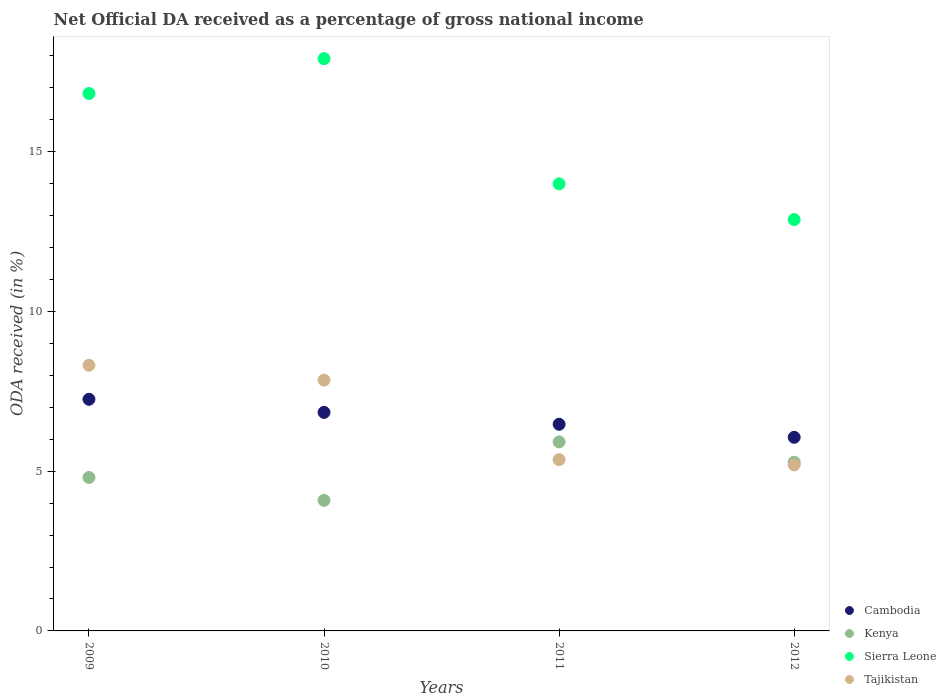How many different coloured dotlines are there?
Your answer should be compact. 4. Is the number of dotlines equal to the number of legend labels?
Your answer should be very brief. Yes. What is the net official DA received in Cambodia in 2011?
Offer a very short reply. 6.47. Across all years, what is the maximum net official DA received in Tajikistan?
Provide a succinct answer. 8.32. Across all years, what is the minimum net official DA received in Sierra Leone?
Offer a very short reply. 12.87. In which year was the net official DA received in Kenya maximum?
Your answer should be very brief. 2011. In which year was the net official DA received in Sierra Leone minimum?
Keep it short and to the point. 2012. What is the total net official DA received in Kenya in the graph?
Provide a succinct answer. 20.09. What is the difference between the net official DA received in Cambodia in 2009 and that in 2012?
Keep it short and to the point. 1.19. What is the difference between the net official DA received in Sierra Leone in 2009 and the net official DA received in Cambodia in 2012?
Offer a terse response. 10.76. What is the average net official DA received in Kenya per year?
Your answer should be very brief. 5.02. In the year 2009, what is the difference between the net official DA received in Cambodia and net official DA received in Tajikistan?
Your response must be concise. -1.07. In how many years, is the net official DA received in Cambodia greater than 2 %?
Your response must be concise. 4. What is the ratio of the net official DA received in Kenya in 2011 to that in 2012?
Provide a short and direct response. 1.12. What is the difference between the highest and the second highest net official DA received in Kenya?
Keep it short and to the point. 0.64. What is the difference between the highest and the lowest net official DA received in Tajikistan?
Offer a very short reply. 3.12. In how many years, is the net official DA received in Cambodia greater than the average net official DA received in Cambodia taken over all years?
Provide a succinct answer. 2. Is the sum of the net official DA received in Kenya in 2009 and 2010 greater than the maximum net official DA received in Tajikistan across all years?
Provide a succinct answer. Yes. Is it the case that in every year, the sum of the net official DA received in Kenya and net official DA received in Cambodia  is greater than the net official DA received in Tajikistan?
Offer a very short reply. Yes. Does the net official DA received in Sierra Leone monotonically increase over the years?
Give a very brief answer. No. Is the net official DA received in Sierra Leone strictly greater than the net official DA received in Cambodia over the years?
Provide a succinct answer. Yes. How many years are there in the graph?
Offer a terse response. 4. Are the values on the major ticks of Y-axis written in scientific E-notation?
Your answer should be very brief. No. Does the graph contain any zero values?
Provide a succinct answer. No. What is the title of the graph?
Your response must be concise. Net Official DA received as a percentage of gross national income. What is the label or title of the X-axis?
Make the answer very short. Years. What is the label or title of the Y-axis?
Your answer should be compact. ODA received (in %). What is the ODA received (in %) of Cambodia in 2009?
Give a very brief answer. 7.25. What is the ODA received (in %) in Kenya in 2009?
Provide a succinct answer. 4.8. What is the ODA received (in %) in Sierra Leone in 2009?
Make the answer very short. 16.82. What is the ODA received (in %) of Tajikistan in 2009?
Provide a succinct answer. 8.32. What is the ODA received (in %) in Cambodia in 2010?
Your answer should be compact. 6.84. What is the ODA received (in %) of Kenya in 2010?
Provide a succinct answer. 4.09. What is the ODA received (in %) of Sierra Leone in 2010?
Your response must be concise. 17.91. What is the ODA received (in %) in Tajikistan in 2010?
Offer a terse response. 7.85. What is the ODA received (in %) in Cambodia in 2011?
Ensure brevity in your answer.  6.47. What is the ODA received (in %) of Kenya in 2011?
Provide a short and direct response. 5.92. What is the ODA received (in %) of Sierra Leone in 2011?
Offer a terse response. 13.99. What is the ODA received (in %) in Tajikistan in 2011?
Give a very brief answer. 5.36. What is the ODA received (in %) in Cambodia in 2012?
Your response must be concise. 6.06. What is the ODA received (in %) in Kenya in 2012?
Provide a short and direct response. 5.28. What is the ODA received (in %) in Sierra Leone in 2012?
Provide a succinct answer. 12.87. What is the ODA received (in %) of Tajikistan in 2012?
Give a very brief answer. 5.2. Across all years, what is the maximum ODA received (in %) in Cambodia?
Offer a very short reply. 7.25. Across all years, what is the maximum ODA received (in %) of Kenya?
Give a very brief answer. 5.92. Across all years, what is the maximum ODA received (in %) in Sierra Leone?
Your answer should be compact. 17.91. Across all years, what is the maximum ODA received (in %) of Tajikistan?
Your answer should be compact. 8.32. Across all years, what is the minimum ODA received (in %) of Cambodia?
Offer a terse response. 6.06. Across all years, what is the minimum ODA received (in %) of Kenya?
Your answer should be very brief. 4.09. Across all years, what is the minimum ODA received (in %) of Sierra Leone?
Ensure brevity in your answer.  12.87. Across all years, what is the minimum ODA received (in %) in Tajikistan?
Provide a succinct answer. 5.2. What is the total ODA received (in %) of Cambodia in the graph?
Offer a terse response. 26.62. What is the total ODA received (in %) in Kenya in the graph?
Offer a very short reply. 20.09. What is the total ODA received (in %) of Sierra Leone in the graph?
Offer a terse response. 61.6. What is the total ODA received (in %) of Tajikistan in the graph?
Offer a very short reply. 26.72. What is the difference between the ODA received (in %) of Cambodia in 2009 and that in 2010?
Provide a short and direct response. 0.41. What is the difference between the ODA received (in %) of Kenya in 2009 and that in 2010?
Offer a terse response. 0.72. What is the difference between the ODA received (in %) in Sierra Leone in 2009 and that in 2010?
Keep it short and to the point. -1.09. What is the difference between the ODA received (in %) in Tajikistan in 2009 and that in 2010?
Your response must be concise. 0.47. What is the difference between the ODA received (in %) of Cambodia in 2009 and that in 2011?
Your response must be concise. 0.78. What is the difference between the ODA received (in %) in Kenya in 2009 and that in 2011?
Your answer should be very brief. -1.11. What is the difference between the ODA received (in %) in Sierra Leone in 2009 and that in 2011?
Give a very brief answer. 2.83. What is the difference between the ODA received (in %) of Tajikistan in 2009 and that in 2011?
Provide a short and direct response. 2.95. What is the difference between the ODA received (in %) in Cambodia in 2009 and that in 2012?
Keep it short and to the point. 1.19. What is the difference between the ODA received (in %) of Kenya in 2009 and that in 2012?
Your answer should be compact. -0.48. What is the difference between the ODA received (in %) in Sierra Leone in 2009 and that in 2012?
Offer a terse response. 3.95. What is the difference between the ODA received (in %) of Tajikistan in 2009 and that in 2012?
Your answer should be compact. 3.12. What is the difference between the ODA received (in %) in Cambodia in 2010 and that in 2011?
Your answer should be very brief. 0.37. What is the difference between the ODA received (in %) of Kenya in 2010 and that in 2011?
Give a very brief answer. -1.83. What is the difference between the ODA received (in %) in Sierra Leone in 2010 and that in 2011?
Your answer should be compact. 3.92. What is the difference between the ODA received (in %) in Tajikistan in 2010 and that in 2011?
Make the answer very short. 2.49. What is the difference between the ODA received (in %) in Cambodia in 2010 and that in 2012?
Your response must be concise. 0.78. What is the difference between the ODA received (in %) in Kenya in 2010 and that in 2012?
Offer a very short reply. -1.19. What is the difference between the ODA received (in %) in Sierra Leone in 2010 and that in 2012?
Your answer should be very brief. 5.04. What is the difference between the ODA received (in %) in Tajikistan in 2010 and that in 2012?
Your response must be concise. 2.65. What is the difference between the ODA received (in %) in Cambodia in 2011 and that in 2012?
Your answer should be compact. 0.41. What is the difference between the ODA received (in %) of Kenya in 2011 and that in 2012?
Make the answer very short. 0.64. What is the difference between the ODA received (in %) of Sierra Leone in 2011 and that in 2012?
Ensure brevity in your answer.  1.12. What is the difference between the ODA received (in %) of Tajikistan in 2011 and that in 2012?
Your answer should be compact. 0.16. What is the difference between the ODA received (in %) of Cambodia in 2009 and the ODA received (in %) of Kenya in 2010?
Offer a terse response. 3.16. What is the difference between the ODA received (in %) in Cambodia in 2009 and the ODA received (in %) in Sierra Leone in 2010?
Make the answer very short. -10.66. What is the difference between the ODA received (in %) in Cambodia in 2009 and the ODA received (in %) in Tajikistan in 2010?
Make the answer very short. -0.6. What is the difference between the ODA received (in %) in Kenya in 2009 and the ODA received (in %) in Sierra Leone in 2010?
Give a very brief answer. -13.11. What is the difference between the ODA received (in %) in Kenya in 2009 and the ODA received (in %) in Tajikistan in 2010?
Ensure brevity in your answer.  -3.04. What is the difference between the ODA received (in %) in Sierra Leone in 2009 and the ODA received (in %) in Tajikistan in 2010?
Provide a succinct answer. 8.97. What is the difference between the ODA received (in %) in Cambodia in 2009 and the ODA received (in %) in Kenya in 2011?
Keep it short and to the point. 1.33. What is the difference between the ODA received (in %) in Cambodia in 2009 and the ODA received (in %) in Sierra Leone in 2011?
Your response must be concise. -6.74. What is the difference between the ODA received (in %) of Cambodia in 2009 and the ODA received (in %) of Tajikistan in 2011?
Give a very brief answer. 1.89. What is the difference between the ODA received (in %) of Kenya in 2009 and the ODA received (in %) of Sierra Leone in 2011?
Provide a succinct answer. -9.19. What is the difference between the ODA received (in %) in Kenya in 2009 and the ODA received (in %) in Tajikistan in 2011?
Offer a terse response. -0.56. What is the difference between the ODA received (in %) of Sierra Leone in 2009 and the ODA received (in %) of Tajikistan in 2011?
Offer a terse response. 11.46. What is the difference between the ODA received (in %) of Cambodia in 2009 and the ODA received (in %) of Kenya in 2012?
Offer a terse response. 1.97. What is the difference between the ODA received (in %) in Cambodia in 2009 and the ODA received (in %) in Sierra Leone in 2012?
Provide a short and direct response. -5.62. What is the difference between the ODA received (in %) of Cambodia in 2009 and the ODA received (in %) of Tajikistan in 2012?
Provide a succinct answer. 2.05. What is the difference between the ODA received (in %) in Kenya in 2009 and the ODA received (in %) in Sierra Leone in 2012?
Make the answer very short. -8.07. What is the difference between the ODA received (in %) of Kenya in 2009 and the ODA received (in %) of Tajikistan in 2012?
Provide a short and direct response. -0.39. What is the difference between the ODA received (in %) in Sierra Leone in 2009 and the ODA received (in %) in Tajikistan in 2012?
Your response must be concise. 11.62. What is the difference between the ODA received (in %) of Cambodia in 2010 and the ODA received (in %) of Kenya in 2011?
Offer a very short reply. 0.92. What is the difference between the ODA received (in %) of Cambodia in 2010 and the ODA received (in %) of Sierra Leone in 2011?
Give a very brief answer. -7.15. What is the difference between the ODA received (in %) of Cambodia in 2010 and the ODA received (in %) of Tajikistan in 2011?
Your answer should be very brief. 1.48. What is the difference between the ODA received (in %) in Kenya in 2010 and the ODA received (in %) in Sierra Leone in 2011?
Keep it short and to the point. -9.91. What is the difference between the ODA received (in %) of Kenya in 2010 and the ODA received (in %) of Tajikistan in 2011?
Your response must be concise. -1.27. What is the difference between the ODA received (in %) in Sierra Leone in 2010 and the ODA received (in %) in Tajikistan in 2011?
Keep it short and to the point. 12.55. What is the difference between the ODA received (in %) of Cambodia in 2010 and the ODA received (in %) of Kenya in 2012?
Your answer should be compact. 1.56. What is the difference between the ODA received (in %) in Cambodia in 2010 and the ODA received (in %) in Sierra Leone in 2012?
Provide a short and direct response. -6.03. What is the difference between the ODA received (in %) in Cambodia in 2010 and the ODA received (in %) in Tajikistan in 2012?
Your response must be concise. 1.64. What is the difference between the ODA received (in %) of Kenya in 2010 and the ODA received (in %) of Sierra Leone in 2012?
Provide a short and direct response. -8.79. What is the difference between the ODA received (in %) of Kenya in 2010 and the ODA received (in %) of Tajikistan in 2012?
Keep it short and to the point. -1.11. What is the difference between the ODA received (in %) in Sierra Leone in 2010 and the ODA received (in %) in Tajikistan in 2012?
Make the answer very short. 12.71. What is the difference between the ODA received (in %) in Cambodia in 2011 and the ODA received (in %) in Kenya in 2012?
Provide a succinct answer. 1.19. What is the difference between the ODA received (in %) of Cambodia in 2011 and the ODA received (in %) of Sierra Leone in 2012?
Give a very brief answer. -6.41. What is the difference between the ODA received (in %) of Cambodia in 2011 and the ODA received (in %) of Tajikistan in 2012?
Your answer should be compact. 1.27. What is the difference between the ODA received (in %) in Kenya in 2011 and the ODA received (in %) in Sierra Leone in 2012?
Ensure brevity in your answer.  -6.96. What is the difference between the ODA received (in %) of Kenya in 2011 and the ODA received (in %) of Tajikistan in 2012?
Give a very brief answer. 0.72. What is the difference between the ODA received (in %) in Sierra Leone in 2011 and the ODA received (in %) in Tajikistan in 2012?
Provide a short and direct response. 8.8. What is the average ODA received (in %) of Cambodia per year?
Offer a terse response. 6.65. What is the average ODA received (in %) in Kenya per year?
Offer a very short reply. 5.02. What is the average ODA received (in %) of Sierra Leone per year?
Offer a terse response. 15.4. What is the average ODA received (in %) in Tajikistan per year?
Offer a very short reply. 6.68. In the year 2009, what is the difference between the ODA received (in %) of Cambodia and ODA received (in %) of Kenya?
Offer a terse response. 2.45. In the year 2009, what is the difference between the ODA received (in %) of Cambodia and ODA received (in %) of Sierra Leone?
Make the answer very short. -9.57. In the year 2009, what is the difference between the ODA received (in %) in Cambodia and ODA received (in %) in Tajikistan?
Provide a succinct answer. -1.07. In the year 2009, what is the difference between the ODA received (in %) of Kenya and ODA received (in %) of Sierra Leone?
Provide a short and direct response. -12.02. In the year 2009, what is the difference between the ODA received (in %) of Kenya and ODA received (in %) of Tajikistan?
Give a very brief answer. -3.51. In the year 2009, what is the difference between the ODA received (in %) of Sierra Leone and ODA received (in %) of Tajikistan?
Your answer should be compact. 8.5. In the year 2010, what is the difference between the ODA received (in %) of Cambodia and ODA received (in %) of Kenya?
Keep it short and to the point. 2.75. In the year 2010, what is the difference between the ODA received (in %) in Cambodia and ODA received (in %) in Sierra Leone?
Your response must be concise. -11.07. In the year 2010, what is the difference between the ODA received (in %) in Cambodia and ODA received (in %) in Tajikistan?
Keep it short and to the point. -1.01. In the year 2010, what is the difference between the ODA received (in %) in Kenya and ODA received (in %) in Sierra Leone?
Provide a succinct answer. -13.82. In the year 2010, what is the difference between the ODA received (in %) in Kenya and ODA received (in %) in Tajikistan?
Offer a terse response. -3.76. In the year 2010, what is the difference between the ODA received (in %) in Sierra Leone and ODA received (in %) in Tajikistan?
Your answer should be very brief. 10.06. In the year 2011, what is the difference between the ODA received (in %) of Cambodia and ODA received (in %) of Kenya?
Ensure brevity in your answer.  0.55. In the year 2011, what is the difference between the ODA received (in %) in Cambodia and ODA received (in %) in Sierra Leone?
Your response must be concise. -7.53. In the year 2011, what is the difference between the ODA received (in %) of Cambodia and ODA received (in %) of Tajikistan?
Keep it short and to the point. 1.11. In the year 2011, what is the difference between the ODA received (in %) in Kenya and ODA received (in %) in Sierra Leone?
Provide a short and direct response. -8.08. In the year 2011, what is the difference between the ODA received (in %) in Kenya and ODA received (in %) in Tajikistan?
Your response must be concise. 0.56. In the year 2011, what is the difference between the ODA received (in %) in Sierra Leone and ODA received (in %) in Tajikistan?
Offer a terse response. 8.63. In the year 2012, what is the difference between the ODA received (in %) in Cambodia and ODA received (in %) in Kenya?
Ensure brevity in your answer.  0.78. In the year 2012, what is the difference between the ODA received (in %) of Cambodia and ODA received (in %) of Sierra Leone?
Ensure brevity in your answer.  -6.82. In the year 2012, what is the difference between the ODA received (in %) in Cambodia and ODA received (in %) in Tajikistan?
Your answer should be very brief. 0.86. In the year 2012, what is the difference between the ODA received (in %) in Kenya and ODA received (in %) in Sierra Leone?
Make the answer very short. -7.59. In the year 2012, what is the difference between the ODA received (in %) of Kenya and ODA received (in %) of Tajikistan?
Offer a terse response. 0.08. In the year 2012, what is the difference between the ODA received (in %) in Sierra Leone and ODA received (in %) in Tajikistan?
Your answer should be very brief. 7.68. What is the ratio of the ODA received (in %) of Cambodia in 2009 to that in 2010?
Offer a very short reply. 1.06. What is the ratio of the ODA received (in %) of Kenya in 2009 to that in 2010?
Your answer should be very brief. 1.18. What is the ratio of the ODA received (in %) of Sierra Leone in 2009 to that in 2010?
Give a very brief answer. 0.94. What is the ratio of the ODA received (in %) in Tajikistan in 2009 to that in 2010?
Ensure brevity in your answer.  1.06. What is the ratio of the ODA received (in %) in Cambodia in 2009 to that in 2011?
Offer a terse response. 1.12. What is the ratio of the ODA received (in %) in Kenya in 2009 to that in 2011?
Offer a very short reply. 0.81. What is the ratio of the ODA received (in %) of Sierra Leone in 2009 to that in 2011?
Your answer should be very brief. 1.2. What is the ratio of the ODA received (in %) of Tajikistan in 2009 to that in 2011?
Offer a very short reply. 1.55. What is the ratio of the ODA received (in %) of Cambodia in 2009 to that in 2012?
Offer a very short reply. 1.2. What is the ratio of the ODA received (in %) of Kenya in 2009 to that in 2012?
Provide a succinct answer. 0.91. What is the ratio of the ODA received (in %) in Sierra Leone in 2009 to that in 2012?
Your answer should be compact. 1.31. What is the ratio of the ODA received (in %) in Tajikistan in 2009 to that in 2012?
Your answer should be compact. 1.6. What is the ratio of the ODA received (in %) of Cambodia in 2010 to that in 2011?
Your response must be concise. 1.06. What is the ratio of the ODA received (in %) in Kenya in 2010 to that in 2011?
Your response must be concise. 0.69. What is the ratio of the ODA received (in %) of Sierra Leone in 2010 to that in 2011?
Offer a very short reply. 1.28. What is the ratio of the ODA received (in %) in Tajikistan in 2010 to that in 2011?
Your answer should be compact. 1.46. What is the ratio of the ODA received (in %) of Cambodia in 2010 to that in 2012?
Provide a short and direct response. 1.13. What is the ratio of the ODA received (in %) of Kenya in 2010 to that in 2012?
Offer a terse response. 0.77. What is the ratio of the ODA received (in %) in Sierra Leone in 2010 to that in 2012?
Keep it short and to the point. 1.39. What is the ratio of the ODA received (in %) in Tajikistan in 2010 to that in 2012?
Ensure brevity in your answer.  1.51. What is the ratio of the ODA received (in %) in Cambodia in 2011 to that in 2012?
Provide a short and direct response. 1.07. What is the ratio of the ODA received (in %) of Kenya in 2011 to that in 2012?
Your response must be concise. 1.12. What is the ratio of the ODA received (in %) of Sierra Leone in 2011 to that in 2012?
Offer a very short reply. 1.09. What is the ratio of the ODA received (in %) in Tajikistan in 2011 to that in 2012?
Give a very brief answer. 1.03. What is the difference between the highest and the second highest ODA received (in %) in Cambodia?
Your response must be concise. 0.41. What is the difference between the highest and the second highest ODA received (in %) in Kenya?
Your answer should be very brief. 0.64. What is the difference between the highest and the second highest ODA received (in %) in Sierra Leone?
Make the answer very short. 1.09. What is the difference between the highest and the second highest ODA received (in %) in Tajikistan?
Your answer should be compact. 0.47. What is the difference between the highest and the lowest ODA received (in %) in Cambodia?
Ensure brevity in your answer.  1.19. What is the difference between the highest and the lowest ODA received (in %) in Kenya?
Ensure brevity in your answer.  1.83. What is the difference between the highest and the lowest ODA received (in %) of Sierra Leone?
Ensure brevity in your answer.  5.04. What is the difference between the highest and the lowest ODA received (in %) of Tajikistan?
Your answer should be compact. 3.12. 